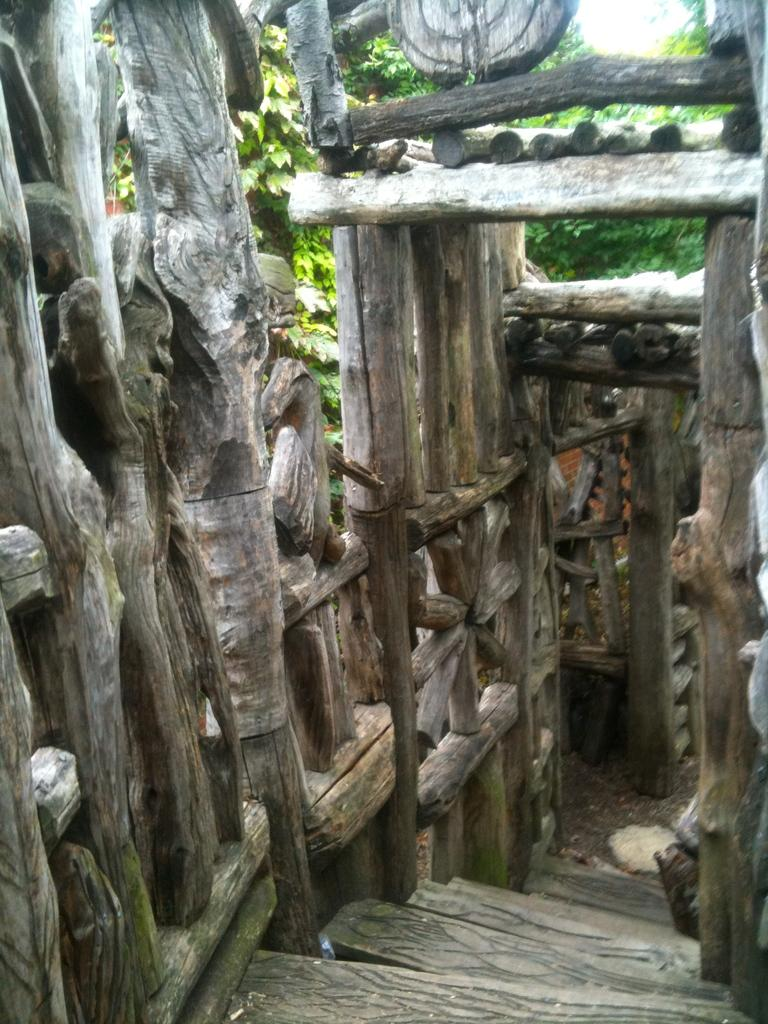What type of structure is visible in the image? There is a wooden structure in the image. What material is used to build the structure? The wooden logs are part of the wooden structure. Does the wooden structure have any specific features? Yes, the wooden structure has steps. What can be seen in the background of the image? There are trees in the background of the image. What channel is the wooden structure tuned to in the image? There is no television or channel present in the image; it features a wooden structure with steps and trees in the background. 